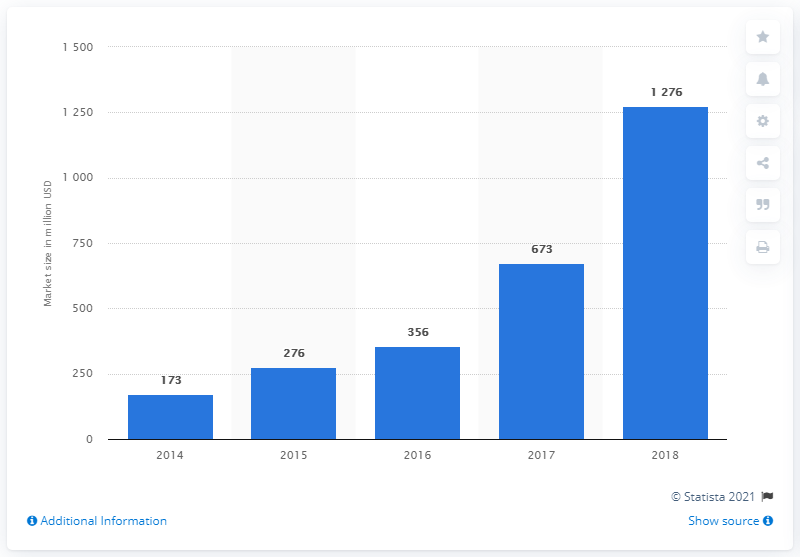Identify some key points in this picture. In 2014, the market size of alternative finance in Germany was 173. 